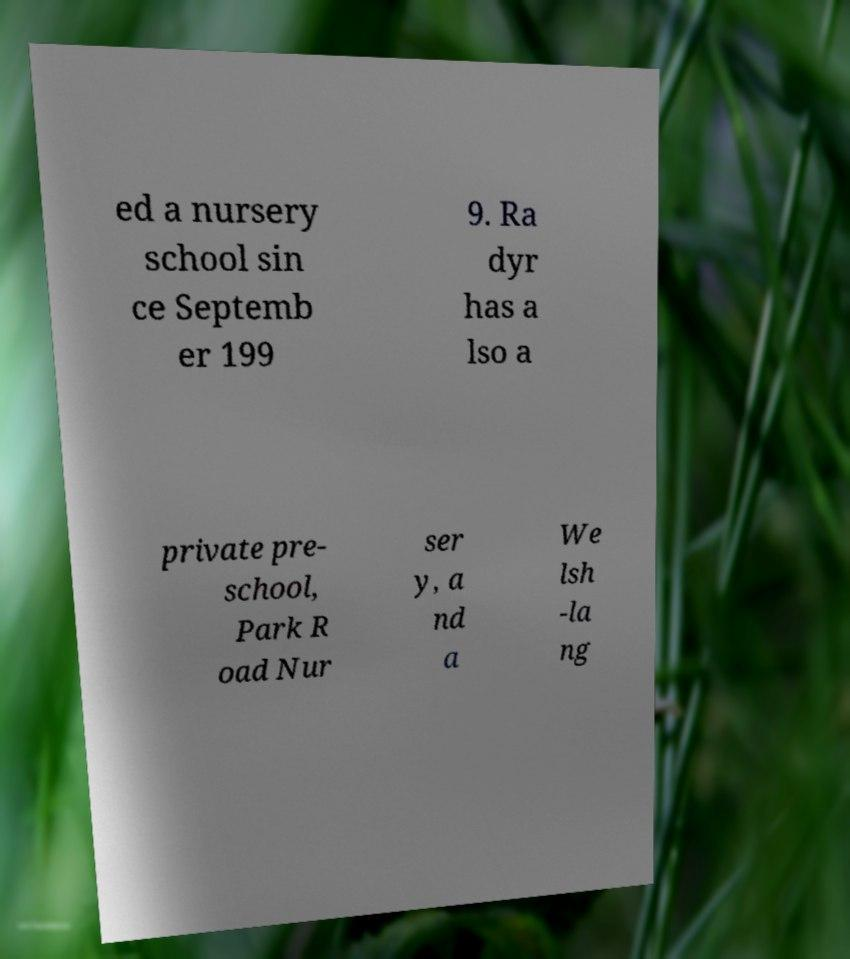Please read and relay the text visible in this image. What does it say? ed a nursery school sin ce Septemb er 199 9. Ra dyr has a lso a private pre- school, Park R oad Nur ser y, a nd a We lsh -la ng 